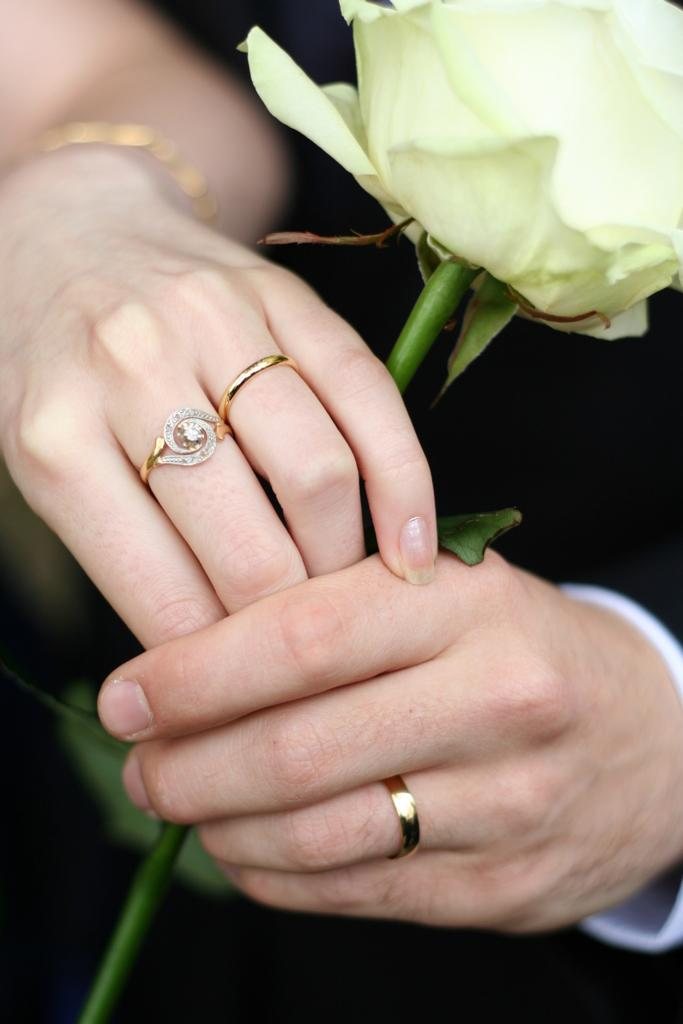What can be seen in the image involving fingers? There are two hands in the image, and three rings are on the fingers. What other object is present in the image? There is a flower in the image. What year is depicted in the image? The image does not depict a specific year; it only shows hands, rings, and a flower. Can you see a pear in the image? There is no pear present in the image. 